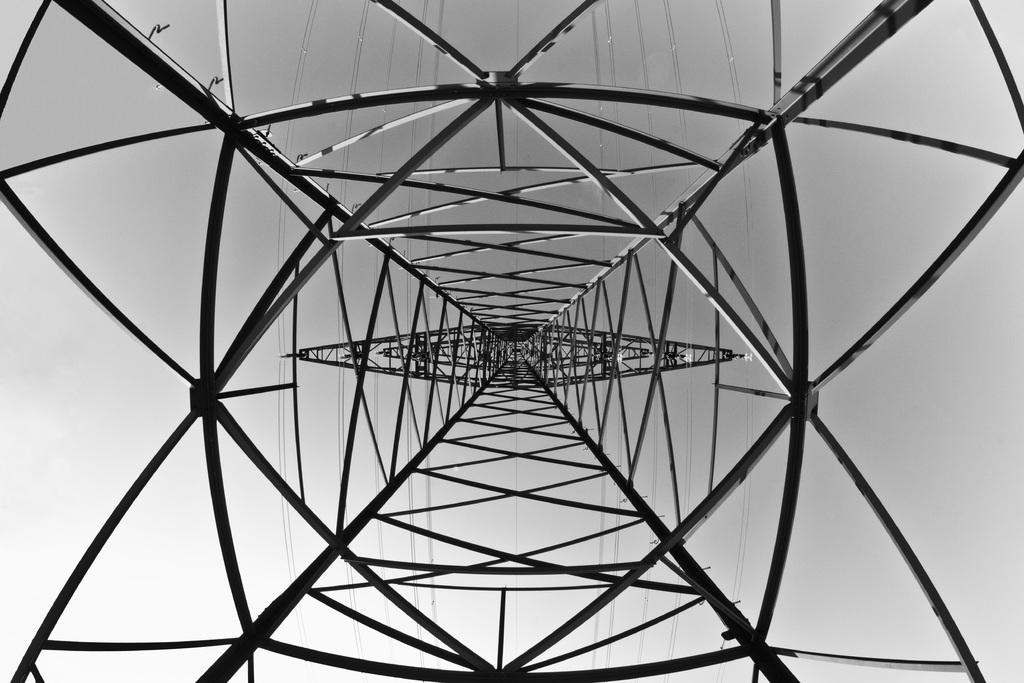What type of location is depicted in the image? The image is an inside view of a tower. What can be seen in the background of the image? The sky is visible in the background of the image. What activity is the carpenter performing in the image? There is no carpenter present in the image. How many fingers can be seen in the image? There is no reference to fingers in the image, as it is an inside view of a tower with the sky visible in the background. 